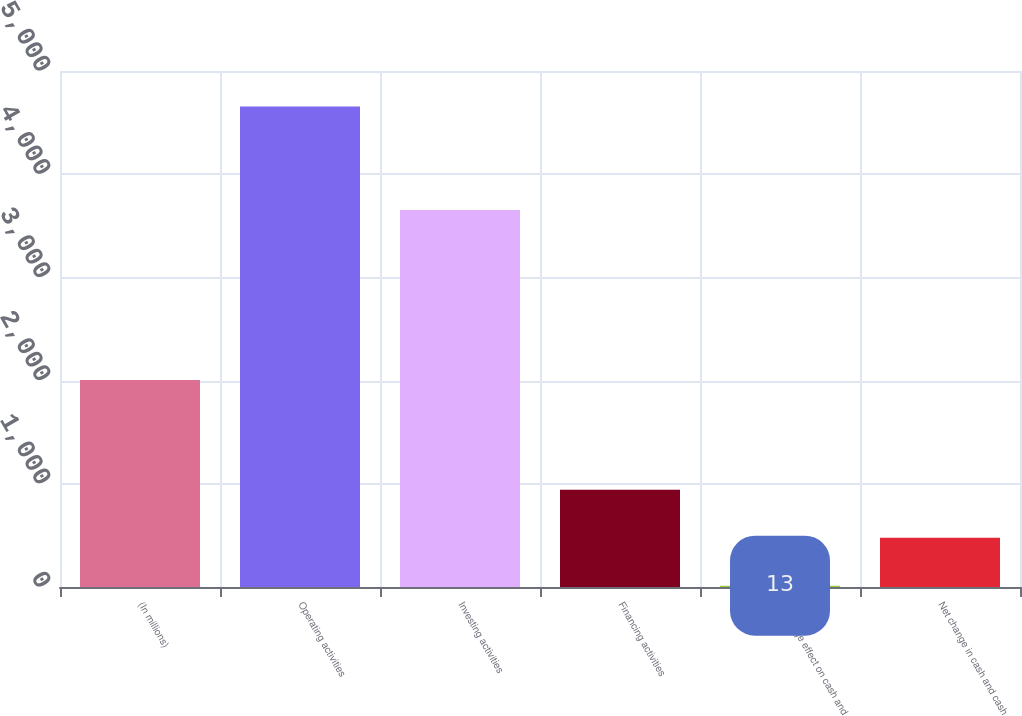Convert chart to OTSL. <chart><loc_0><loc_0><loc_500><loc_500><bar_chart><fcel>(In millions)<fcel>Operating activities<fcel>Investing activities<fcel>Financing activities<fcel>Exchange effect on cash and<fcel>Net change in cash and cash<nl><fcel>2007<fcel>4656<fcel>3654<fcel>941.6<fcel>13<fcel>477.3<nl></chart> 